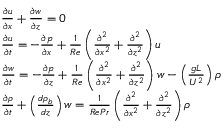<formula> <loc_0><loc_0><loc_500><loc_500>\begin{array} { r l } & { \frac { \partial u } { \partial x } + \frac { \partial w } { \partial z } = 0 } \\ & { \frac { \partial u } { \partial t } = - \frac { \partial p } { \partial x } + \frac { 1 } { R e } \left ( \frac { \partial ^ { 2 } } { \partial x ^ { 2 } } + \frac { \partial ^ { 2 } } { \partial z ^ { 2 } } \right ) u } \\ & { \frac { \partial w } { \partial t } = - \frac { \partial p } { \partial z } + \frac { 1 } { R e } \left ( \frac { \partial ^ { 2 } } { \partial x ^ { 2 } } + \frac { \partial ^ { 2 } } { \partial z ^ { 2 } } \right ) w - \left ( \frac { g L } { U ^ { 2 } } \right ) \rho } \\ & { \frac { \partial \rho } { \partial t } + \left ( \frac { d \rho _ { b } } { d z } \right ) w = \frac { 1 } { R e P r } \left ( \frac { \partial ^ { 2 } } { \partial x ^ { 2 } } + \frac { \partial ^ { 2 } } { \partial z ^ { 2 } } \right ) \rho } \end{array}</formula> 